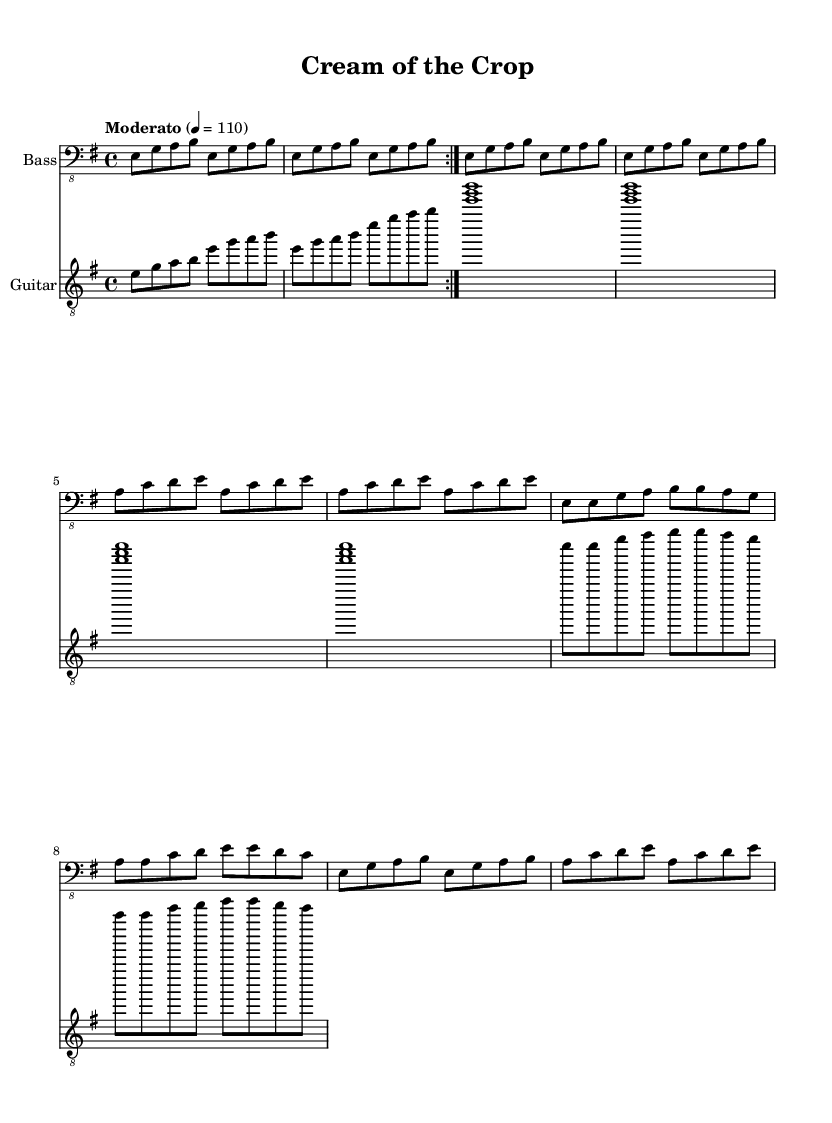What is the key signature of this music? The key signature is E minor, which has one sharp (F#). It can be identified at the beginning of the sheet music where the key signature is indicated.
Answer: E minor What is the time signature of this piece? The time signature is 4/4, which is explicitly shown in the initial part of the score, indicating four beats per measure.
Answer: 4/4 What is the tempo marking of the piece? The tempo marking is "Moderato," and it is indicated in the score with a tempo of 110 beats per minute.
Answer: Moderato How many measures are in the Verse section? The Verse consists of four measures, observed by counting the respective music notations within the assigned Verse section.
Answer: Four What harmonic structure is used in the Verse? The harmonic structure incorporates the chords E minor and A minor, as noted within the chord changes indicated for the Verse section.
Answer: E minor and A minor How does the bass guitar interact with the guitar in the Chorus? The bass guitar plays a rhythmic pattern that complements the chords played by the guitar, creating a solid groove characteristic of electric blues.
Answer: Rhythmic pattern complementing chords What is the overall form of the piece? The overall form follows a verse-chorus structure, alternating between the Verse and Chorus sections, typical in blues music to create a cyclic feel.
Answer: Verse-Chorus 